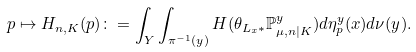Convert formula to latex. <formula><loc_0><loc_0><loc_500><loc_500>p \mapsto H _ { n , K } ( p ) \colon = \int _ { Y } \int _ { \pi ^ { - 1 } ( y ) } H ( \theta _ { L _ { x } \ast } \mathbb { P } _ { \mu , n | K } ^ { y } ) d \eta _ { p } ^ { y } ( x ) d \nu ( y ) .</formula> 